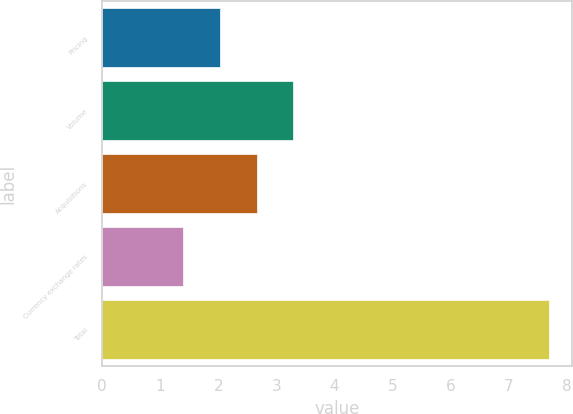Convert chart. <chart><loc_0><loc_0><loc_500><loc_500><bar_chart><fcel>Pricing<fcel>Volume<fcel>Acquisitions<fcel>Currency exchange rates<fcel>Total<nl><fcel>2.03<fcel>3.29<fcel>2.66<fcel>1.4<fcel>7.7<nl></chart> 